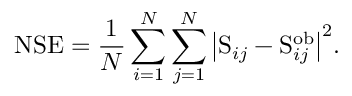<formula> <loc_0><loc_0><loc_500><loc_500>N S E = \frac { 1 } { N } \sum _ { i = 1 } ^ { N } \sum _ { j = 1 } ^ { N } { \left | S _ { i j } - S _ { i j } ^ { o b } \right | } ^ { 2 } .</formula> 